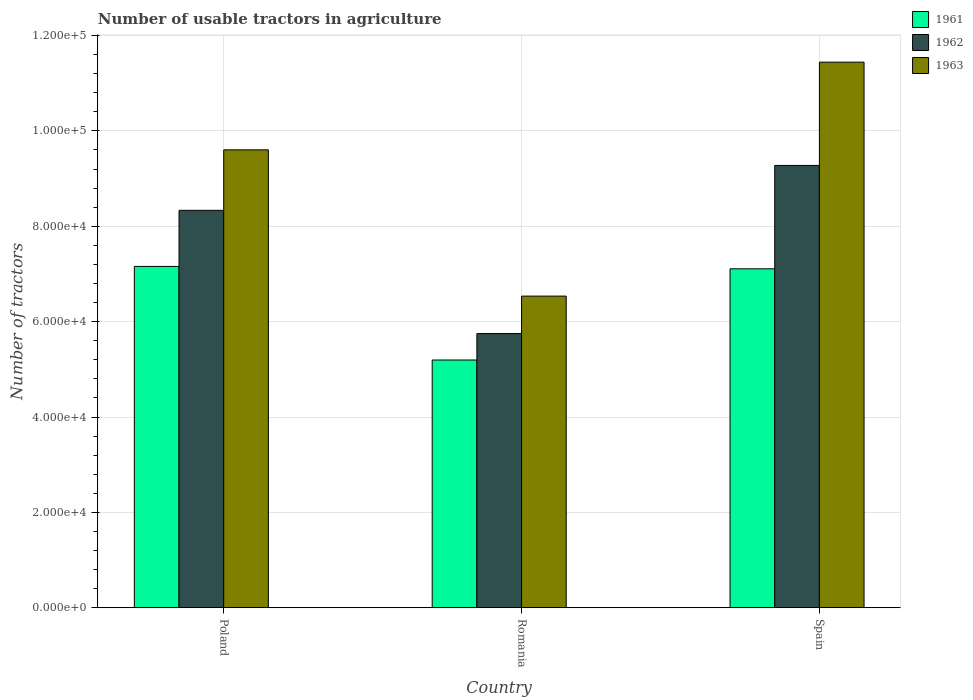How many different coloured bars are there?
Keep it short and to the point. 3. Are the number of bars on each tick of the X-axis equal?
Your response must be concise. Yes. How many bars are there on the 1st tick from the left?
Your answer should be compact. 3. What is the number of usable tractors in agriculture in 1963 in Spain?
Offer a terse response. 1.14e+05. Across all countries, what is the maximum number of usable tractors in agriculture in 1961?
Your answer should be very brief. 7.16e+04. Across all countries, what is the minimum number of usable tractors in agriculture in 1963?
Your response must be concise. 6.54e+04. In which country was the number of usable tractors in agriculture in 1963 minimum?
Provide a short and direct response. Romania. What is the total number of usable tractors in agriculture in 1963 in the graph?
Give a very brief answer. 2.76e+05. What is the difference between the number of usable tractors in agriculture in 1962 in Poland and that in Romania?
Provide a succinct answer. 2.58e+04. What is the difference between the number of usable tractors in agriculture in 1961 in Romania and the number of usable tractors in agriculture in 1962 in Poland?
Your answer should be compact. -3.14e+04. What is the average number of usable tractors in agriculture in 1961 per country?
Give a very brief answer. 6.49e+04. What is the difference between the number of usable tractors in agriculture of/in 1962 and number of usable tractors in agriculture of/in 1961 in Spain?
Provide a succinct answer. 2.17e+04. What is the ratio of the number of usable tractors in agriculture in 1963 in Romania to that in Spain?
Your answer should be compact. 0.57. Is the number of usable tractors in agriculture in 1961 in Poland less than that in Romania?
Provide a short and direct response. No. What is the difference between the highest and the second highest number of usable tractors in agriculture in 1961?
Your answer should be very brief. -1.96e+04. What is the difference between the highest and the lowest number of usable tractors in agriculture in 1963?
Offer a very short reply. 4.91e+04. In how many countries, is the number of usable tractors in agriculture in 1963 greater than the average number of usable tractors in agriculture in 1963 taken over all countries?
Your response must be concise. 2. Is the sum of the number of usable tractors in agriculture in 1963 in Poland and Romania greater than the maximum number of usable tractors in agriculture in 1961 across all countries?
Ensure brevity in your answer.  Yes. What does the 1st bar from the left in Romania represents?
Provide a succinct answer. 1961. Is it the case that in every country, the sum of the number of usable tractors in agriculture in 1962 and number of usable tractors in agriculture in 1961 is greater than the number of usable tractors in agriculture in 1963?
Provide a short and direct response. Yes. How many bars are there?
Provide a short and direct response. 9. How many countries are there in the graph?
Your answer should be compact. 3. How are the legend labels stacked?
Provide a short and direct response. Vertical. What is the title of the graph?
Offer a terse response. Number of usable tractors in agriculture. What is the label or title of the Y-axis?
Your answer should be compact. Number of tractors. What is the Number of tractors of 1961 in Poland?
Ensure brevity in your answer.  7.16e+04. What is the Number of tractors of 1962 in Poland?
Ensure brevity in your answer.  8.33e+04. What is the Number of tractors of 1963 in Poland?
Your response must be concise. 9.60e+04. What is the Number of tractors in 1961 in Romania?
Keep it short and to the point. 5.20e+04. What is the Number of tractors of 1962 in Romania?
Make the answer very short. 5.75e+04. What is the Number of tractors of 1963 in Romania?
Give a very brief answer. 6.54e+04. What is the Number of tractors of 1961 in Spain?
Make the answer very short. 7.11e+04. What is the Number of tractors in 1962 in Spain?
Give a very brief answer. 9.28e+04. What is the Number of tractors of 1963 in Spain?
Your answer should be compact. 1.14e+05. Across all countries, what is the maximum Number of tractors of 1961?
Your answer should be compact. 7.16e+04. Across all countries, what is the maximum Number of tractors of 1962?
Keep it short and to the point. 9.28e+04. Across all countries, what is the maximum Number of tractors in 1963?
Your answer should be very brief. 1.14e+05. Across all countries, what is the minimum Number of tractors in 1961?
Offer a terse response. 5.20e+04. Across all countries, what is the minimum Number of tractors of 1962?
Provide a succinct answer. 5.75e+04. Across all countries, what is the minimum Number of tractors in 1963?
Your answer should be compact. 6.54e+04. What is the total Number of tractors in 1961 in the graph?
Your answer should be compact. 1.95e+05. What is the total Number of tractors in 1962 in the graph?
Your answer should be very brief. 2.34e+05. What is the total Number of tractors in 1963 in the graph?
Your answer should be very brief. 2.76e+05. What is the difference between the Number of tractors of 1961 in Poland and that in Romania?
Your response must be concise. 1.96e+04. What is the difference between the Number of tractors in 1962 in Poland and that in Romania?
Keep it short and to the point. 2.58e+04. What is the difference between the Number of tractors of 1963 in Poland and that in Romania?
Provide a short and direct response. 3.07e+04. What is the difference between the Number of tractors in 1962 in Poland and that in Spain?
Provide a succinct answer. -9414. What is the difference between the Number of tractors in 1963 in Poland and that in Spain?
Make the answer very short. -1.84e+04. What is the difference between the Number of tractors of 1961 in Romania and that in Spain?
Provide a succinct answer. -1.91e+04. What is the difference between the Number of tractors in 1962 in Romania and that in Spain?
Offer a terse response. -3.53e+04. What is the difference between the Number of tractors of 1963 in Romania and that in Spain?
Offer a very short reply. -4.91e+04. What is the difference between the Number of tractors of 1961 in Poland and the Number of tractors of 1962 in Romania?
Offer a very short reply. 1.41e+04. What is the difference between the Number of tractors of 1961 in Poland and the Number of tractors of 1963 in Romania?
Provide a short and direct response. 6226. What is the difference between the Number of tractors in 1962 in Poland and the Number of tractors in 1963 in Romania?
Your answer should be very brief. 1.80e+04. What is the difference between the Number of tractors of 1961 in Poland and the Number of tractors of 1962 in Spain?
Ensure brevity in your answer.  -2.12e+04. What is the difference between the Number of tractors of 1961 in Poland and the Number of tractors of 1963 in Spain?
Your response must be concise. -4.28e+04. What is the difference between the Number of tractors of 1962 in Poland and the Number of tractors of 1963 in Spain?
Your answer should be very brief. -3.11e+04. What is the difference between the Number of tractors of 1961 in Romania and the Number of tractors of 1962 in Spain?
Your response must be concise. -4.08e+04. What is the difference between the Number of tractors of 1961 in Romania and the Number of tractors of 1963 in Spain?
Ensure brevity in your answer.  -6.25e+04. What is the difference between the Number of tractors of 1962 in Romania and the Number of tractors of 1963 in Spain?
Give a very brief answer. -5.69e+04. What is the average Number of tractors of 1961 per country?
Your answer should be compact. 6.49e+04. What is the average Number of tractors in 1962 per country?
Make the answer very short. 7.79e+04. What is the average Number of tractors of 1963 per country?
Your answer should be compact. 9.19e+04. What is the difference between the Number of tractors of 1961 and Number of tractors of 1962 in Poland?
Give a very brief answer. -1.18e+04. What is the difference between the Number of tractors in 1961 and Number of tractors in 1963 in Poland?
Make the answer very short. -2.44e+04. What is the difference between the Number of tractors of 1962 and Number of tractors of 1963 in Poland?
Offer a terse response. -1.27e+04. What is the difference between the Number of tractors of 1961 and Number of tractors of 1962 in Romania?
Offer a terse response. -5548. What is the difference between the Number of tractors of 1961 and Number of tractors of 1963 in Romania?
Your answer should be compact. -1.34e+04. What is the difference between the Number of tractors of 1962 and Number of tractors of 1963 in Romania?
Provide a short and direct response. -7851. What is the difference between the Number of tractors in 1961 and Number of tractors in 1962 in Spain?
Make the answer very short. -2.17e+04. What is the difference between the Number of tractors of 1961 and Number of tractors of 1963 in Spain?
Give a very brief answer. -4.33e+04. What is the difference between the Number of tractors in 1962 and Number of tractors in 1963 in Spain?
Ensure brevity in your answer.  -2.17e+04. What is the ratio of the Number of tractors of 1961 in Poland to that in Romania?
Your answer should be very brief. 1.38. What is the ratio of the Number of tractors in 1962 in Poland to that in Romania?
Ensure brevity in your answer.  1.45. What is the ratio of the Number of tractors of 1963 in Poland to that in Romania?
Offer a very short reply. 1.47. What is the ratio of the Number of tractors of 1961 in Poland to that in Spain?
Give a very brief answer. 1.01. What is the ratio of the Number of tractors of 1962 in Poland to that in Spain?
Keep it short and to the point. 0.9. What is the ratio of the Number of tractors in 1963 in Poland to that in Spain?
Keep it short and to the point. 0.84. What is the ratio of the Number of tractors of 1961 in Romania to that in Spain?
Your answer should be compact. 0.73. What is the ratio of the Number of tractors in 1962 in Romania to that in Spain?
Provide a short and direct response. 0.62. What is the ratio of the Number of tractors in 1963 in Romania to that in Spain?
Provide a succinct answer. 0.57. What is the difference between the highest and the second highest Number of tractors in 1962?
Ensure brevity in your answer.  9414. What is the difference between the highest and the second highest Number of tractors of 1963?
Give a very brief answer. 1.84e+04. What is the difference between the highest and the lowest Number of tractors in 1961?
Your answer should be compact. 1.96e+04. What is the difference between the highest and the lowest Number of tractors in 1962?
Offer a terse response. 3.53e+04. What is the difference between the highest and the lowest Number of tractors in 1963?
Keep it short and to the point. 4.91e+04. 